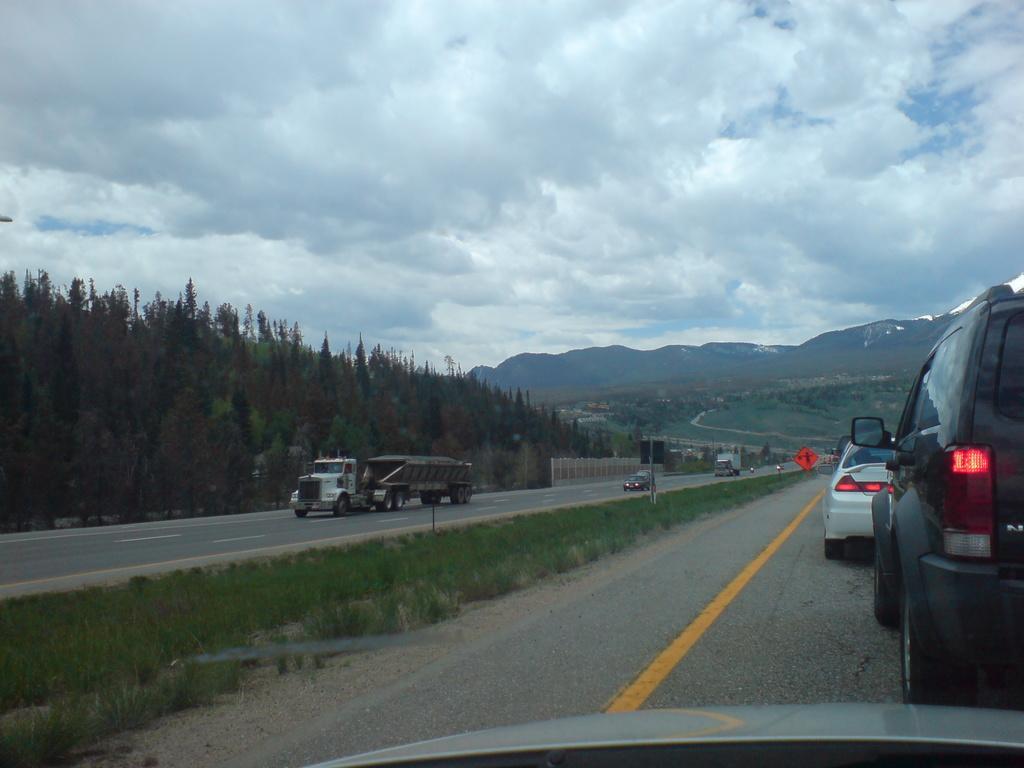Could you give a brief overview of what you see in this image? In this image there are a few vehicles moving on the road, in the background there are trees, mountains and the sky. 